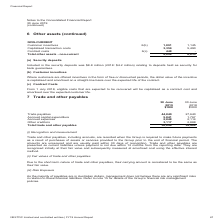According to Nextdc's financial document, How was trade payables recognised and measured? recognised initially at their fair value and subsequently measured at amortised cost using the effective interest method.. The document states: "within 12 months from the reporting date. They are recognised initially at their fair value and subsequently measured at amortised cost using the effe..." Also, Why was the carrying amount of trade payables considered to be the same as their fair value? Due to the short-term nature of trade and other payables. The document states: "Due to the short-term nature of trade and other payables, their carrying amount is considered to be the same as their fair value...." Also, How much was the trade payables for 2019? According to the financial document, 44,840 (in thousands). The relevant text states: "Trade payables 44,840 27,640 Accrued capital expenditure 5,841 1,767 Accrued expenses 2,848 2,114 Other creditors 3,117 2..." Also, can you calculate: What was the percentage change in accrued expenses between 2018 and 2019? To answer this question, I need to perform calculations using the financial data. The calculation is: (2,848 -2,114) / 2,114 , which equals 34.72 (percentage). This is based on the information: "al expenditure 5,841 1,767 Accrued expenses 2,848 2,114 Other creditors 3,117 2,888 Total trade and other payables 56,646 34,409 capital expenditure 5,841 1,767 Accrued expenses 2,848 2,114 Other cred..." The key data points involved are: 2,114, 2,848. Also, can you calculate: What was the sum of accrued expenses and accrued capital expenditure in 2018? Based on the calculation: 1,767 + 2,114 , the result is 3881 (in thousands). This is based on the information: "s 44,840 27,640 Accrued capital expenditure 5,841 1,767 Accrued expenses 2,848 2,114 Other creditors 3,117 2,888 Total trade and other payables 56,646 34,4 al expenditure 5,841 1,767 Accrued expenses ..." The key data points involved are: 1,767, 2,114. Also, can you calculate: What was the percentage change in total trade and other payables between 2018 and 2019? To answer this question, I need to perform calculations using the financial data. The calculation is: (56,646 - 34,409) / 34,409 , which equals 64.63 (percentage). This is based on the information: "3,117 2,888 Total trade and other payables 56,646 34,409 ditors 3,117 2,888 Total trade and other payables 56,646 34,409..." The key data points involved are: 34,409, 56,646. 